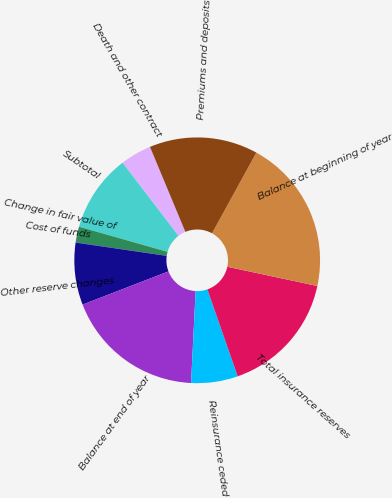Convert chart to OTSL. <chart><loc_0><loc_0><loc_500><loc_500><pie_chart><fcel>Death and other contract<fcel>Subtotal<fcel>Change in fair value of<fcel>Cost of funds<fcel>Other reserve changes<fcel>Balance at end of year<fcel>Reinsurance ceded<fcel>Total insurance reserves<fcel>Balance at beginning of year<fcel>Premiums and deposits<nl><fcel>4.11%<fcel>10.2%<fcel>2.07%<fcel>0.04%<fcel>8.17%<fcel>18.33%<fcel>6.14%<fcel>16.3%<fcel>20.36%<fcel>14.27%<nl></chart> 